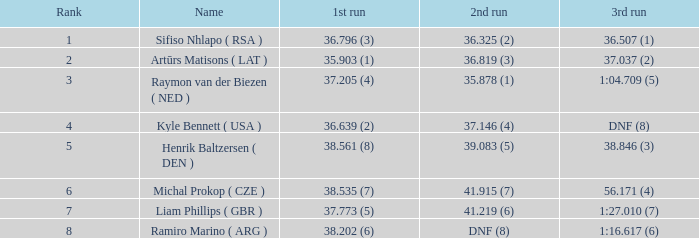Which 3rd run has rank of 1? 36.507 (1). 